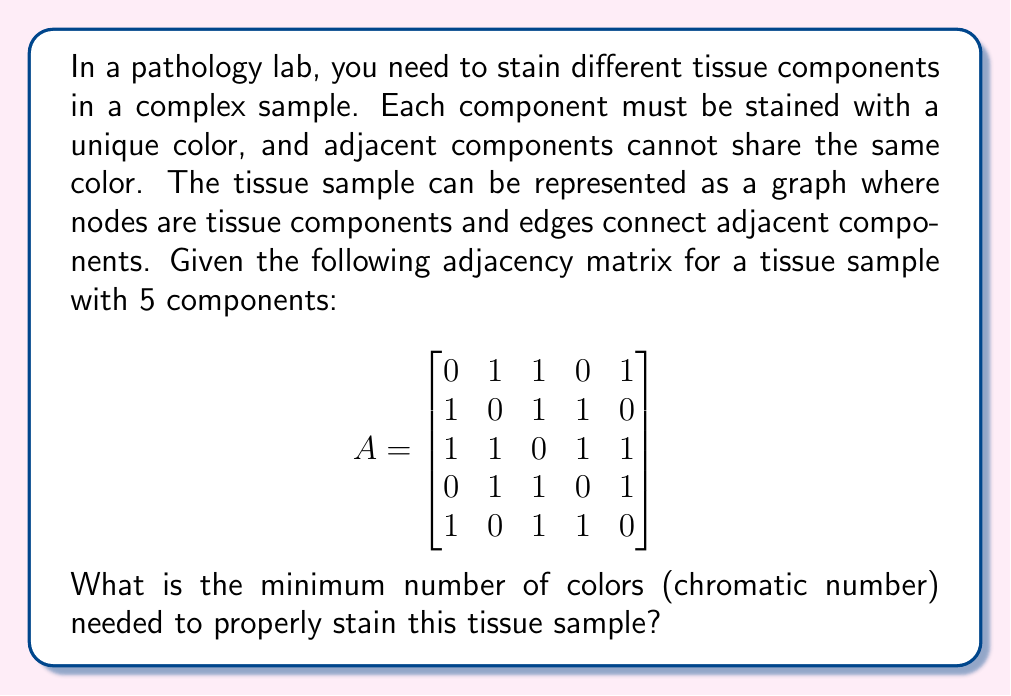Show me your answer to this math problem. To solve this problem, we need to determine the chromatic number of the graph represented by the given adjacency matrix. Let's approach this step-by-step:

1. Interpret the adjacency matrix:
   - Each row/column represents a tissue component (node in the graph).
   - A 1 in position $(i,j)$ means components $i$ and $j$ are adjacent.

2. Visualize the graph:
   - Component 1 is adjacent to 2, 3, and 5
   - Component 2 is adjacent to 1, 3, and 4
   - Component 3 is adjacent to all other components
   - Component 4 is adjacent to 2, 3, and 5
   - Component 5 is adjacent to 1, 3, and 4

3. Apply graph coloring algorithm:
   - Start with component 3 as it has the highest degree (connected to all others).
   - Assign color 1 to component 3.
   - Components 1, 2, 4, and 5 cannot have color 1.
   - Assign color 2 to component 1.
   - Component 2 can't have colors 1 or 2, so assign color 3.
   - Component 4 can have color 2 (it's not adjacent to 1).
   - Component 5 can have color 3 (it's not adjacent to 2).

4. Verify the coloring:
   - No adjacent components share the same color.
   - We used 3 colors in total.

5. Check if we can use fewer colors:
   - We can't use 2 colors because component 3 is adjacent to all others.
   - Therefore, 3 is the minimum number of colors needed.

Thus, the chromatic number of this graph is 3.
Answer: The minimum number of colors (chromatic number) needed to properly stain this tissue sample is 3. 